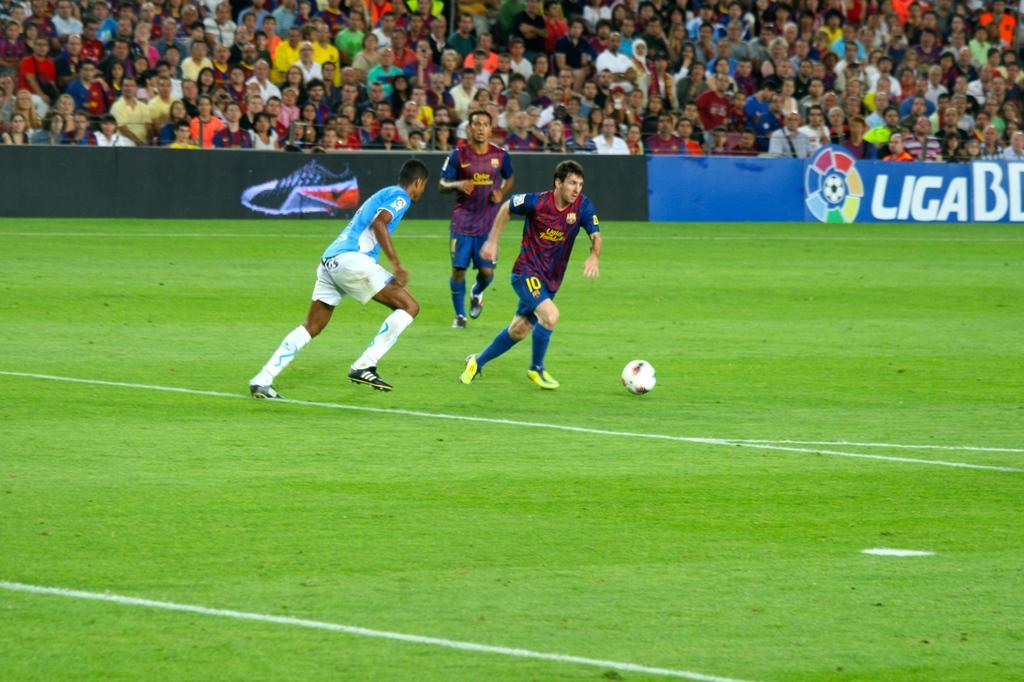How many players are involved in the game in the image? There are three players in the image. What type of surface are the players playing on? They are playing on the ground. What sport are they playing? The game being played is football. Is there any demarcation around the playing area? Yes, there is a boundary around the ground. Who else is present at the location besides the players? There are people sitting in the gallery watching the match. What is the noise level in the image? The noise level cannot be determined from the image, as it is a visual representation and does not include sound. 